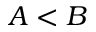<formula> <loc_0><loc_0><loc_500><loc_500>A < B</formula> 